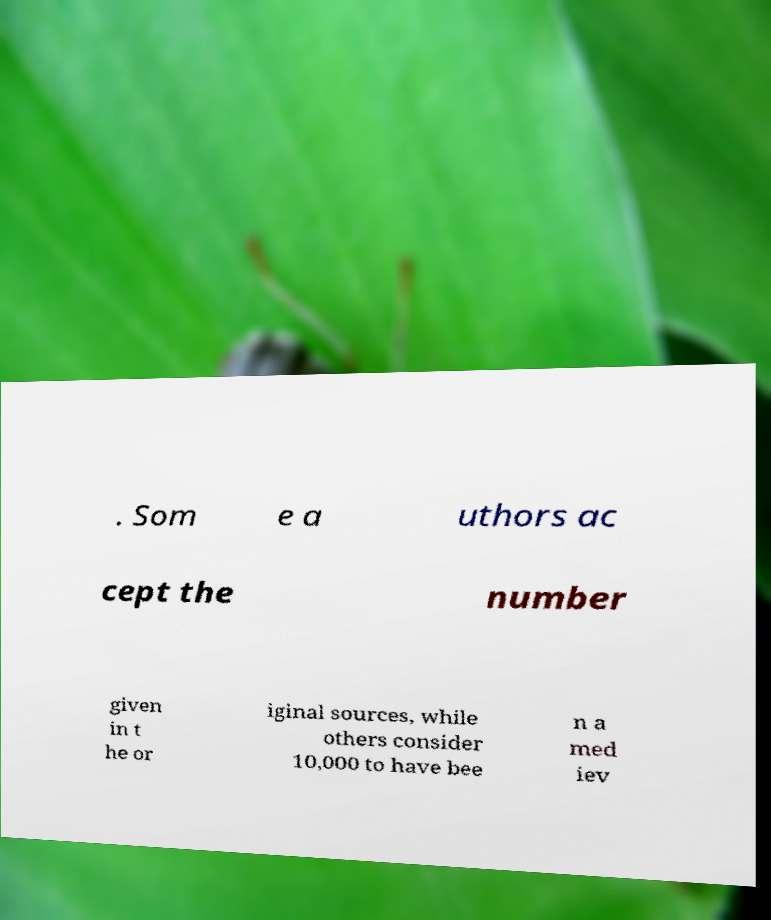Please identify and transcribe the text found in this image. . Som e a uthors ac cept the number given in t he or iginal sources, while others consider 10,000 to have bee n a med iev 